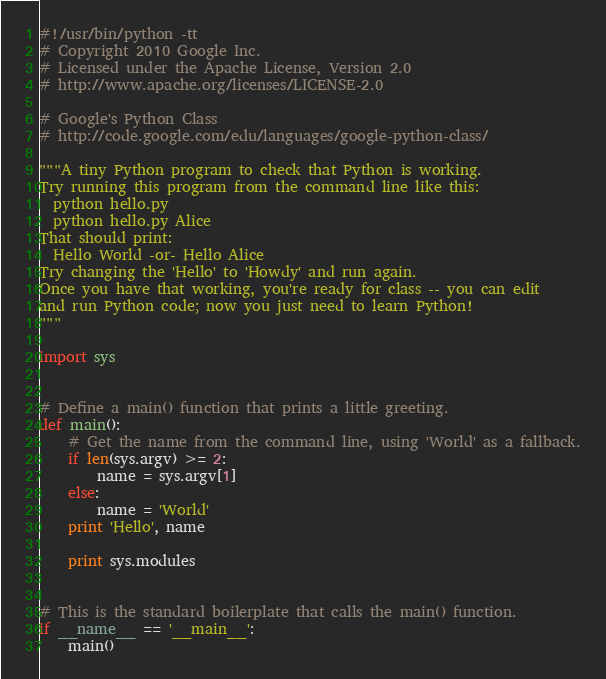<code> <loc_0><loc_0><loc_500><loc_500><_Python_>#!/usr/bin/python -tt
# Copyright 2010 Google Inc.
# Licensed under the Apache License, Version 2.0
# http://www.apache.org/licenses/LICENSE-2.0

# Google's Python Class
# http://code.google.com/edu/languages/google-python-class/

"""A tiny Python program to check that Python is working.
Try running this program from the command line like this:
  python hello.py
  python hello.py Alice
That should print:
  Hello World -or- Hello Alice
Try changing the 'Hello' to 'Howdy' and run again.
Once you have that working, you're ready for class -- you can edit
and run Python code; now you just need to learn Python!
"""

import sys


# Define a main() function that prints a little greeting.
def main():
    # Get the name from the command line, using 'World' as a fallback.
    if len(sys.argv) >= 2:
        name = sys.argv[1]
    else:
        name = 'World'
    print 'Hello', name

    print sys.modules


# This is the standard boilerplate that calls the main() function.
if __name__ == '__main__':
    main()
</code> 